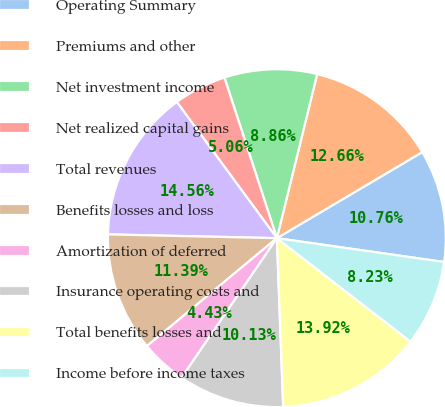<chart> <loc_0><loc_0><loc_500><loc_500><pie_chart><fcel>Operating Summary<fcel>Premiums and other<fcel>Net investment income<fcel>Net realized capital gains<fcel>Total revenues<fcel>Benefits losses and loss<fcel>Amortization of deferred<fcel>Insurance operating costs and<fcel>Total benefits losses and<fcel>Income before income taxes<nl><fcel>10.76%<fcel>12.66%<fcel>8.86%<fcel>5.06%<fcel>14.56%<fcel>11.39%<fcel>4.43%<fcel>10.13%<fcel>13.92%<fcel>8.23%<nl></chart> 